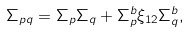Convert formula to latex. <formula><loc_0><loc_0><loc_500><loc_500>\Sigma _ { p q } = \Sigma _ { p } \Sigma _ { q } + \Sigma _ { p } ^ { b } \xi _ { 1 2 } \Sigma _ { q } ^ { b } ,</formula> 